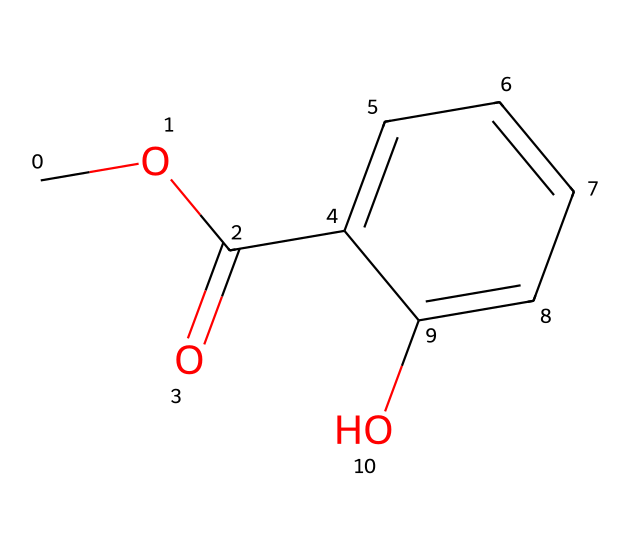How many carbon atoms are in methyl salicylate? The structure contains three distinct carbon atoms from the methyl group (C1), the carbonyl group (C2), and the aromatic ring (C6) which contributes to the total carbon count. Counting these gives a total of nine carbon atoms in the entire molecule.
Answer: nine What functional groups are present in this chemical? The structure reveals several functional groups: the ester functional group is indicated by the carbonyl (C=O) bonded to an oxygen atom (C-O) and the hydroxyl (-OH) group in the aromatic ring. These confirm it has an ester and a phenolic hydroxyl group.
Answer: ester and phenolic What is the degree of unsaturation in methyl salicylate? To determine the degree of unsaturation, I count the rings and double bonds in the structure. The aromatic ring represents one degree of unsaturation, and since there are no additional double bonds or rings, the total is just one.
Answer: one What makes methyl salicylate an effective analgesic? The presence of the ester and the aromatic hydroxyl structure contribute to its ability to interact with pain receptors, which makes it effective as an analgesic. The phenolic -OH group also enhances its activity in reducing pain signals.
Answer: pain receptors Which part of the molecule is responsible for its analgesic properties? The phenolic hydroxyl (-OH) group is essential for binding to pain receptors, thus enhancing its analgesic effect alongside the ester formation, which maintains the overall molecular structure conducive for therapeutic action.
Answer: phenolic hydroxyl group How many total hydrogen atoms are present in methyl salicylate? In the methyl group, there are three hydrogen atoms; the carbonyl carbon does not contribute any, and the aromatic ring contributes four more hydrogen atoms (considering it’s a monosubstituted phenol). Summing them gives a total of eight hydrogen atoms.
Answer: eight 